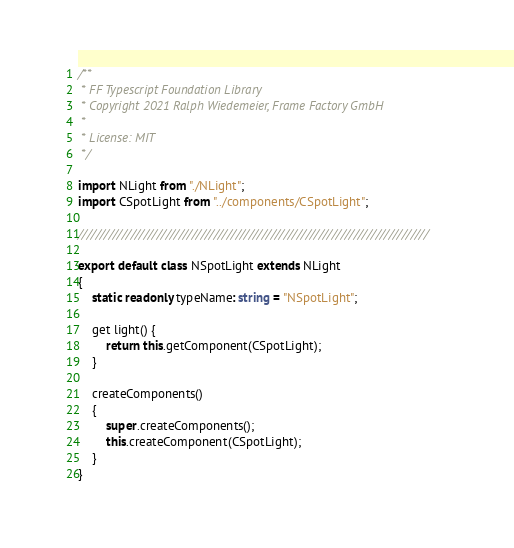<code> <loc_0><loc_0><loc_500><loc_500><_TypeScript_>/**
 * FF Typescript Foundation Library
 * Copyright 2021 Ralph Wiedemeier, Frame Factory GmbH
 *
 * License: MIT
 */

import NLight from "./NLight";
import CSpotLight from "../components/CSpotLight";

////////////////////////////////////////////////////////////////////////////////

export default class NSpotLight extends NLight
{
    static readonly typeName: string = "NSpotLight";

    get light() {
        return this.getComponent(CSpotLight);
    }

    createComponents()
    {
        super.createComponents();
        this.createComponent(CSpotLight);
    }
}</code> 